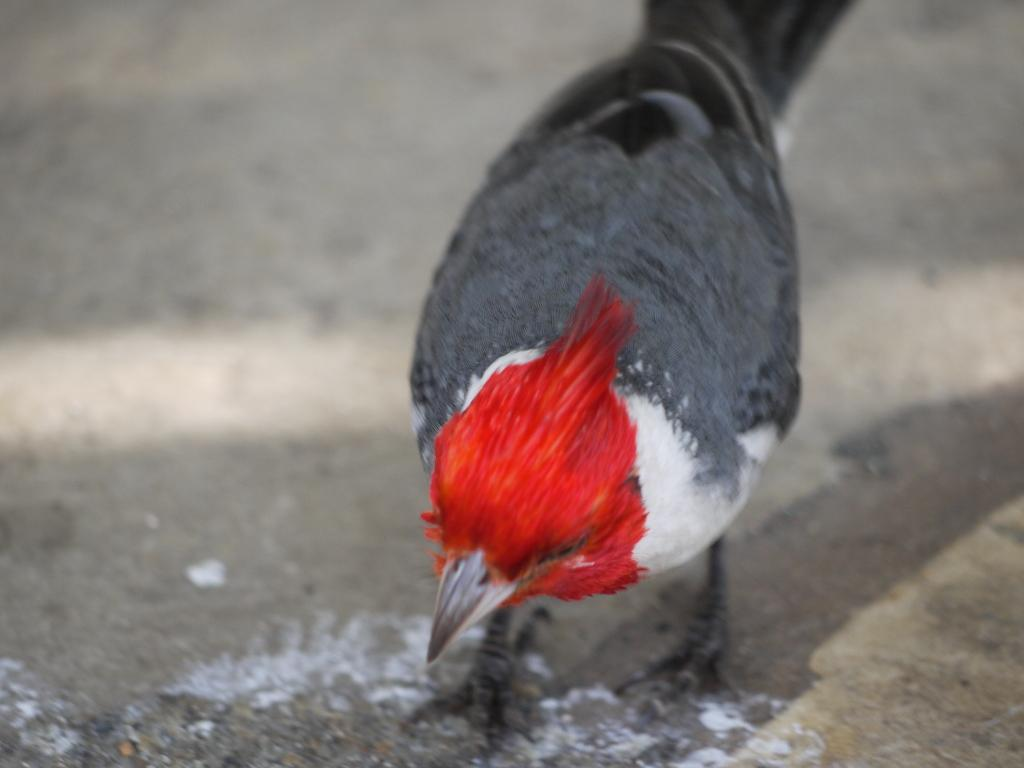What type of animal is on the ground in the image? There is a bird on the ground in the image. Can you describe the background of the image? The background of the image is blurred. What type of dock can be seen in the image? There is no dock present in the image; it features a bird on the ground and a blurred background. 